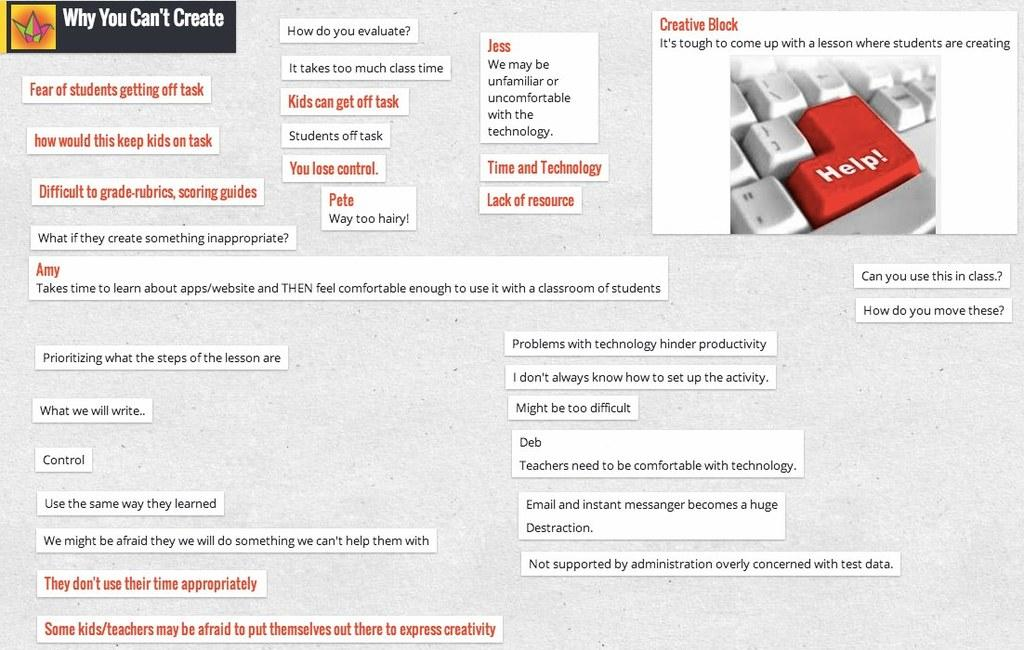<image>
Provide a brief description of the given image. Screenshot of brainstorming "Why You Can't Create" with various ideas listed. 